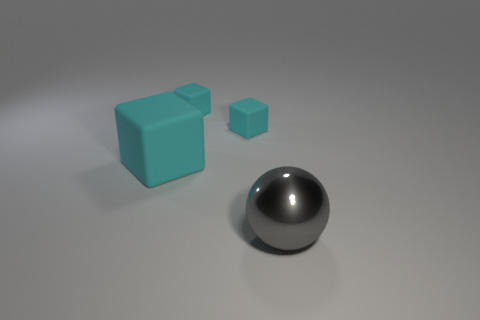Add 3 tiny blue balls. How many objects exist? 7 Subtract all spheres. How many objects are left? 3 Add 3 big gray metal balls. How many big gray metal balls exist? 4 Subtract 0 purple balls. How many objects are left? 4 Subtract all big green shiny objects. Subtract all matte objects. How many objects are left? 1 Add 4 gray things. How many gray things are left? 5 